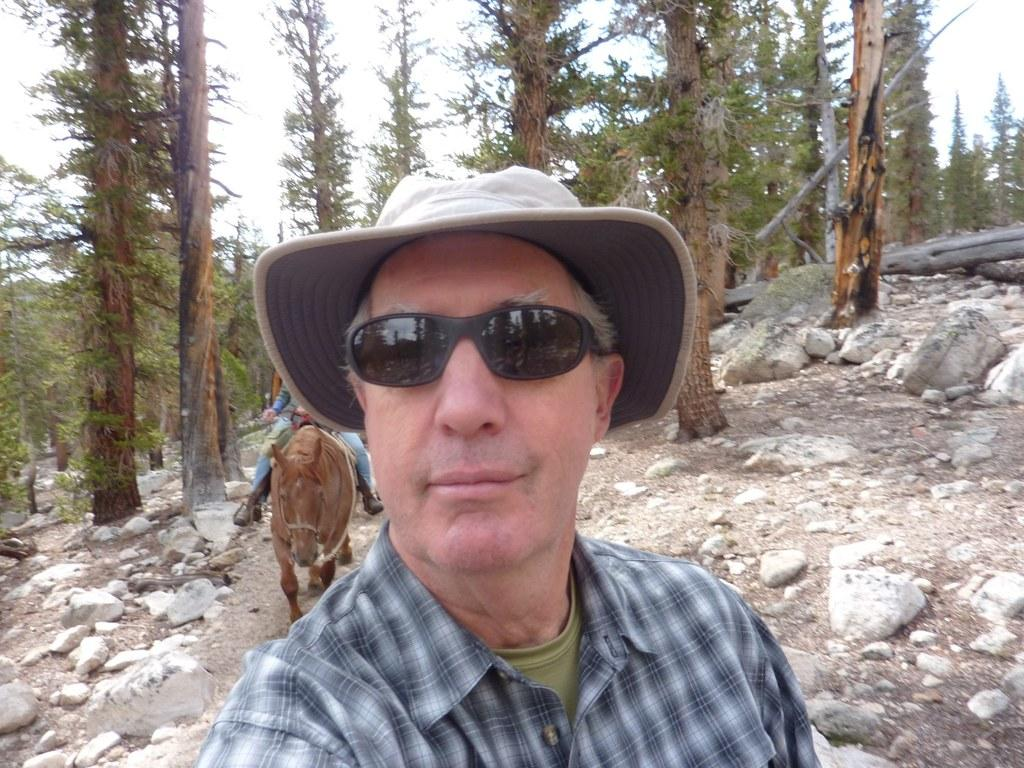What is the person in the image wearing on their face? The person in the image is wearing glasses. What type of headwear is the person in the image wearing? The person in the image is wearing a cap. What is the person sitting on in the image? There is a person sitting on a donkey in the image. What can be seen in the background of the image? Trees and the sky are visible in the background of the image. What type of ground surface is present in the image? There are stones present in the image. What type of paper is the person in the image using to make soup? There is no paper or soup present in the image; the person is wearing glasses and a cap, and sitting on a donkey. 